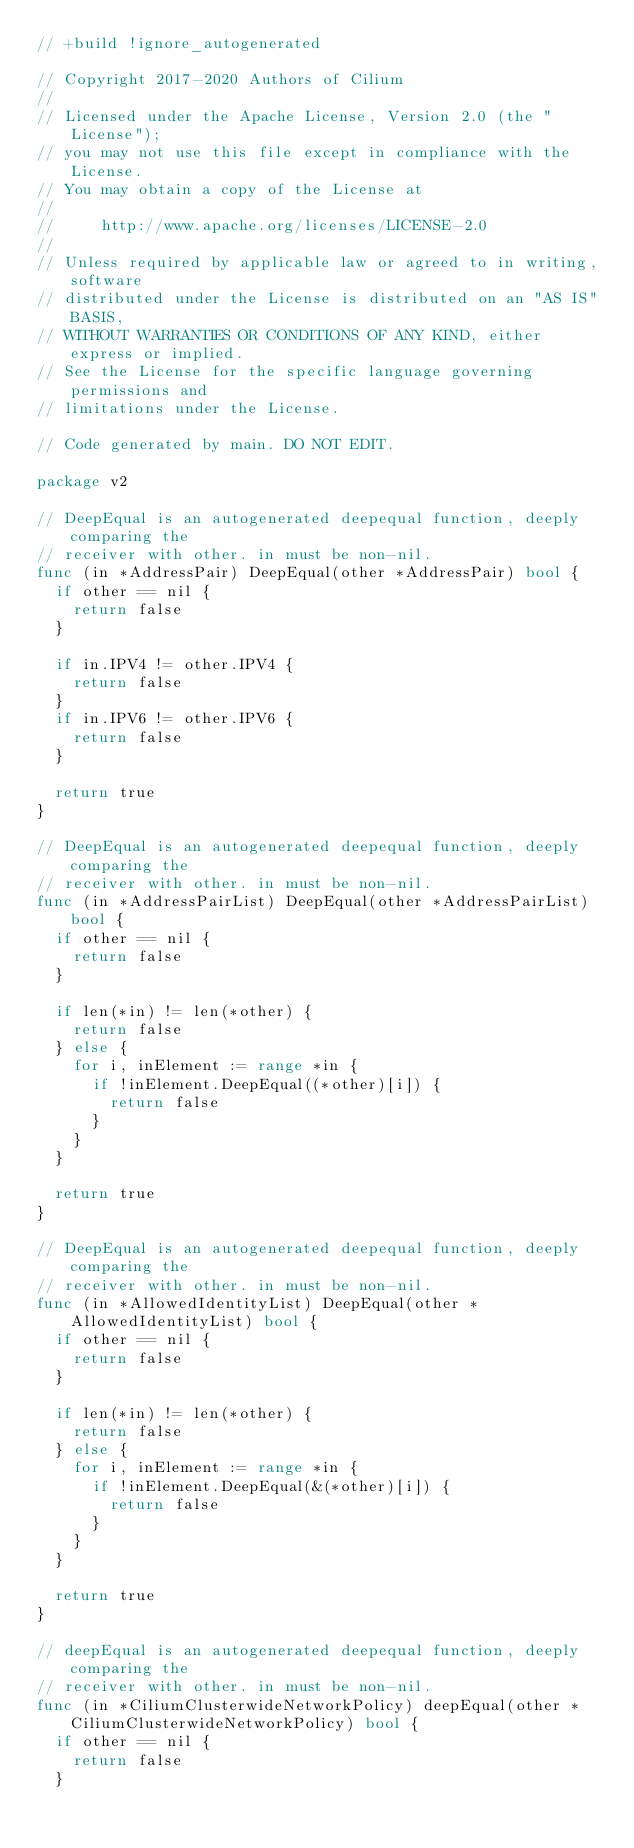Convert code to text. <code><loc_0><loc_0><loc_500><loc_500><_Go_>// +build !ignore_autogenerated

// Copyright 2017-2020 Authors of Cilium
//
// Licensed under the Apache License, Version 2.0 (the "License");
// you may not use this file except in compliance with the License.
// You may obtain a copy of the License at
//
//     http://www.apache.org/licenses/LICENSE-2.0
//
// Unless required by applicable law or agreed to in writing, software
// distributed under the License is distributed on an "AS IS" BASIS,
// WITHOUT WARRANTIES OR CONDITIONS OF ANY KIND, either express or implied.
// See the License for the specific language governing permissions and
// limitations under the License.

// Code generated by main. DO NOT EDIT.

package v2

// DeepEqual is an autogenerated deepequal function, deeply comparing the
// receiver with other. in must be non-nil.
func (in *AddressPair) DeepEqual(other *AddressPair) bool {
	if other == nil {
		return false
	}

	if in.IPV4 != other.IPV4 {
		return false
	}
	if in.IPV6 != other.IPV6 {
		return false
	}

	return true
}

// DeepEqual is an autogenerated deepequal function, deeply comparing the
// receiver with other. in must be non-nil.
func (in *AddressPairList) DeepEqual(other *AddressPairList) bool {
	if other == nil {
		return false
	}

	if len(*in) != len(*other) {
		return false
	} else {
		for i, inElement := range *in {
			if !inElement.DeepEqual((*other)[i]) {
				return false
			}
		}
	}

	return true
}

// DeepEqual is an autogenerated deepequal function, deeply comparing the
// receiver with other. in must be non-nil.
func (in *AllowedIdentityList) DeepEqual(other *AllowedIdentityList) bool {
	if other == nil {
		return false
	}

	if len(*in) != len(*other) {
		return false
	} else {
		for i, inElement := range *in {
			if !inElement.DeepEqual(&(*other)[i]) {
				return false
			}
		}
	}

	return true
}

// deepEqual is an autogenerated deepequal function, deeply comparing the
// receiver with other. in must be non-nil.
func (in *CiliumClusterwideNetworkPolicy) deepEqual(other *CiliumClusterwideNetworkPolicy) bool {
	if other == nil {
		return false
	}
</code> 